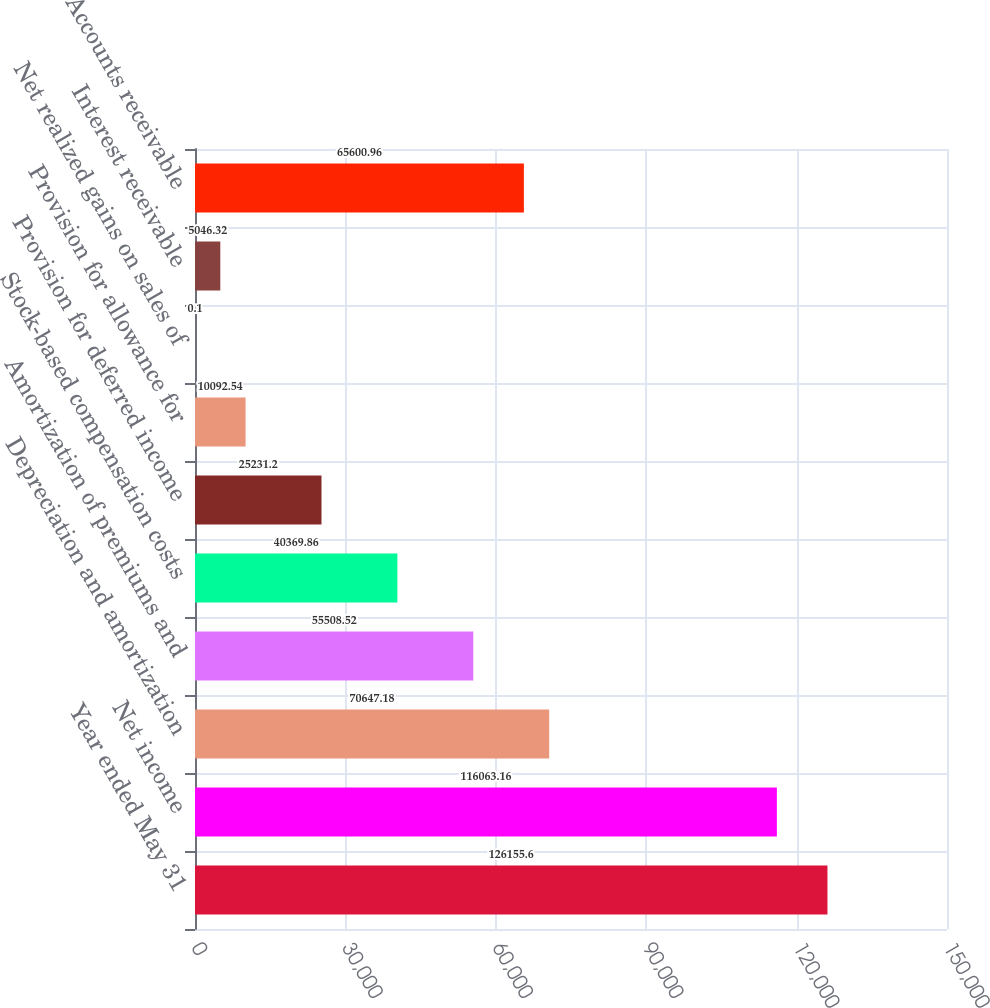Convert chart to OTSL. <chart><loc_0><loc_0><loc_500><loc_500><bar_chart><fcel>Year ended May 31<fcel>Net income<fcel>Depreciation and amortization<fcel>Amortization of premiums and<fcel>Stock-based compensation costs<fcel>Provision for deferred income<fcel>Provision for allowance for<fcel>Net realized gains on sales of<fcel>Interest receivable<fcel>Accounts receivable<nl><fcel>126156<fcel>116063<fcel>70647.2<fcel>55508.5<fcel>40369.9<fcel>25231.2<fcel>10092.5<fcel>0.1<fcel>5046.32<fcel>65601<nl></chart> 